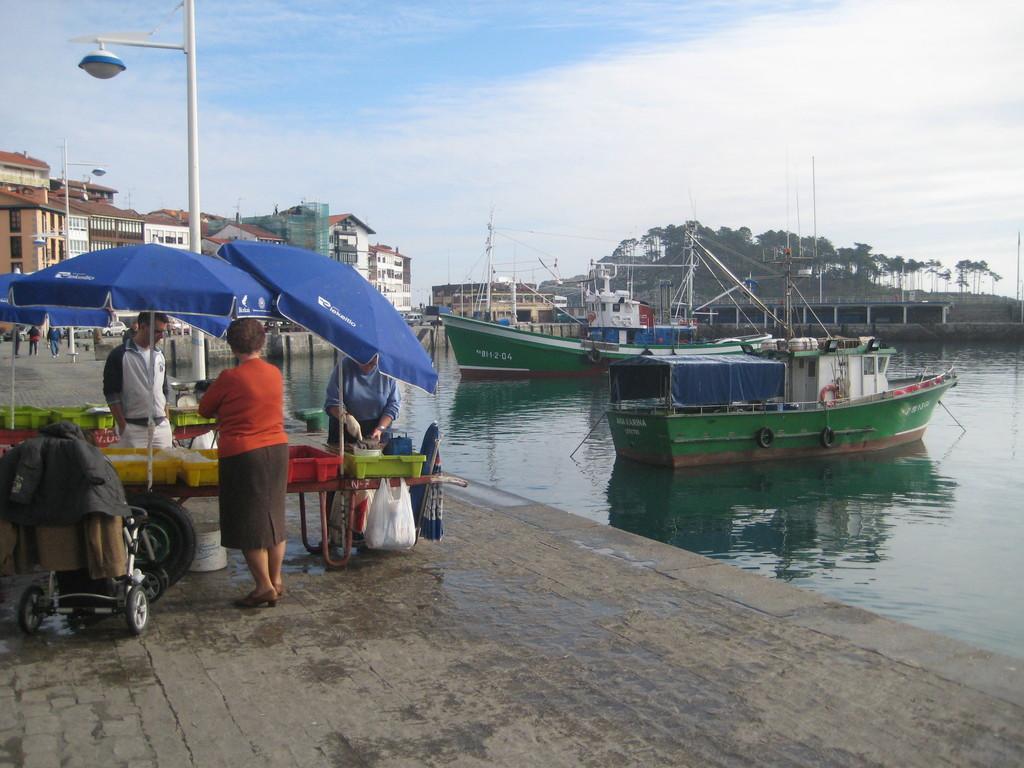Can you describe this image briefly? In this image I can see few boats,water,building,trees,light-poles,blue tents,trolley,few people. One person is holding something. The sky is in blue and white color. 